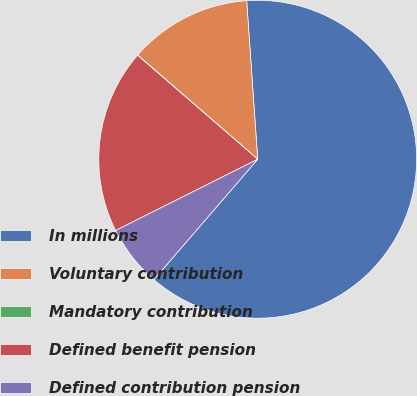Convert chart. <chart><loc_0><loc_0><loc_500><loc_500><pie_chart><fcel>In millions<fcel>Voluntary contribution<fcel>Mandatory contribution<fcel>Defined benefit pension<fcel>Defined contribution pension<nl><fcel>62.43%<fcel>12.51%<fcel>0.03%<fcel>18.75%<fcel>6.27%<nl></chart> 